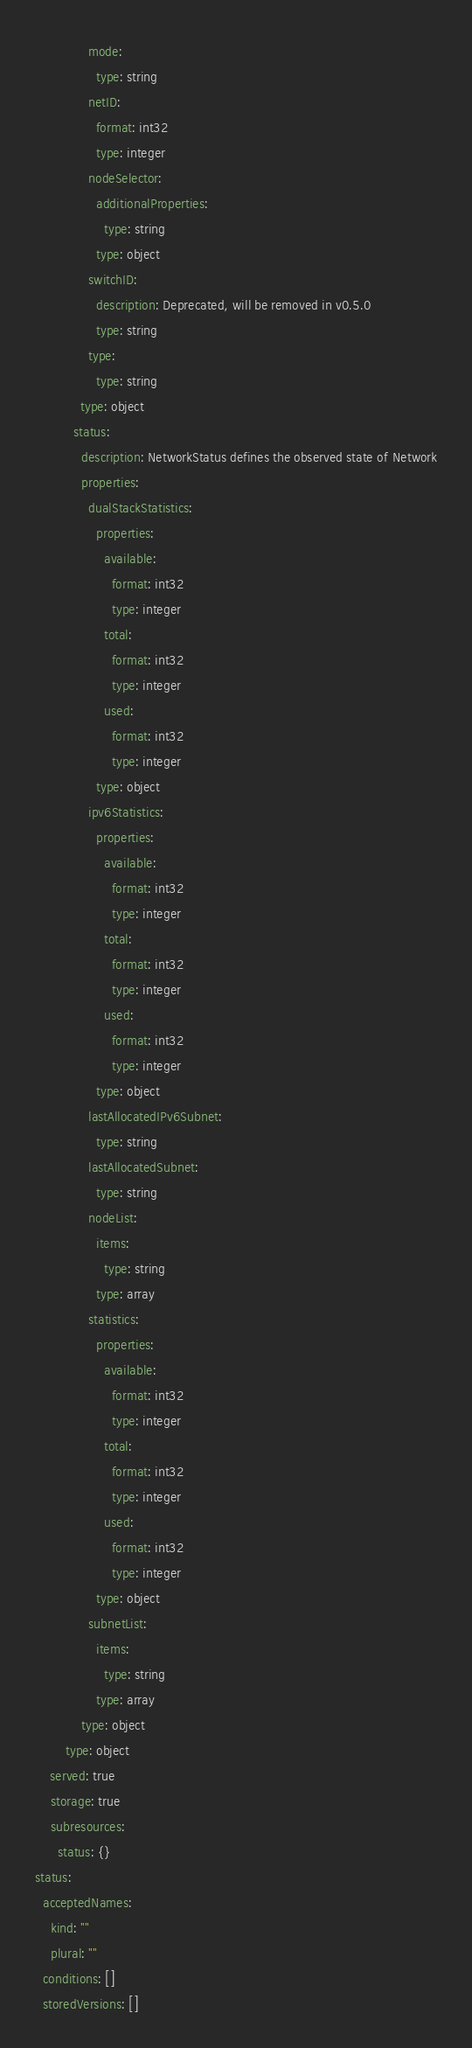Convert code to text. <code><loc_0><loc_0><loc_500><loc_500><_YAML_>              mode:
                type: string
              netID:
                format: int32
                type: integer
              nodeSelector:
                additionalProperties:
                  type: string
                type: object
              switchID:
                description: Deprecated, will be removed in v0.5.0
                type: string
              type:
                type: string
            type: object
          status:
            description: NetworkStatus defines the observed state of Network
            properties:
              dualStackStatistics:
                properties:
                  available:
                    format: int32
                    type: integer
                  total:
                    format: int32
                    type: integer
                  used:
                    format: int32
                    type: integer
                type: object
              ipv6Statistics:
                properties:
                  available:
                    format: int32
                    type: integer
                  total:
                    format: int32
                    type: integer
                  used:
                    format: int32
                    type: integer
                type: object
              lastAllocatedIPv6Subnet:
                type: string
              lastAllocatedSubnet:
                type: string
              nodeList:
                items:
                  type: string
                type: array
              statistics:
                properties:
                  available:
                    format: int32
                    type: integer
                  total:
                    format: int32
                    type: integer
                  used:
                    format: int32
                    type: integer
                type: object
              subnetList:
                items:
                  type: string
                type: array
            type: object
        type: object
    served: true
    storage: true
    subresources:
      status: {}
status:
  acceptedNames:
    kind: ""
    plural: ""
  conditions: []
  storedVersions: []
</code> 